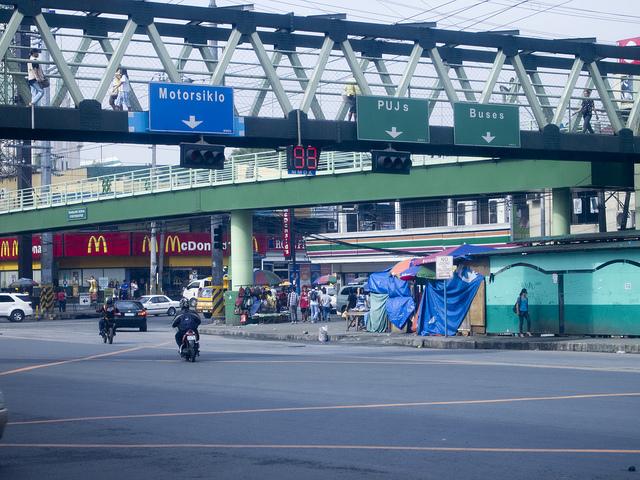What restaurant is in the picture?
Short answer required. Mcdonald's. Is there a bus only lane?
Be succinct. Yes. Is this picture taken in the United States?
Give a very brief answer. No. 